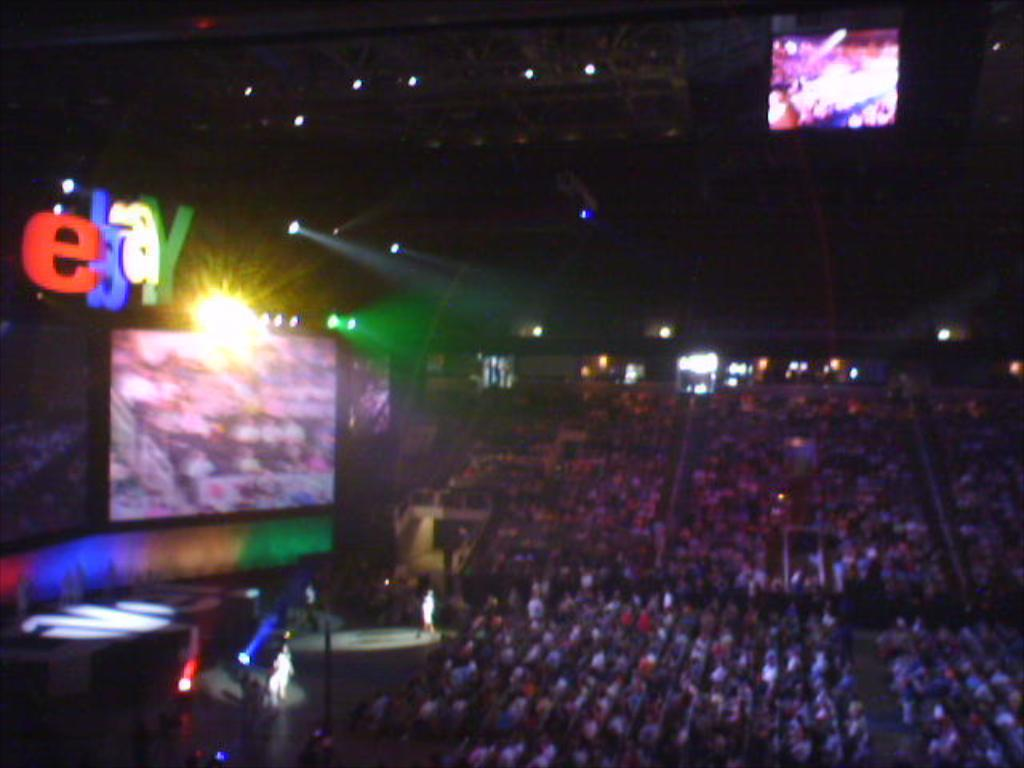<image>
Write a terse but informative summary of the picture. A stadium full of people with a lit ebay sign on the left. 